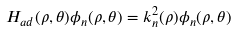Convert formula to latex. <formula><loc_0><loc_0><loc_500><loc_500>H _ { a d } ( \rho , \theta ) \phi _ { n } ( \rho , \theta ) = k _ { n } ^ { 2 } ( \rho ) \phi _ { n } ( \rho , \theta )</formula> 